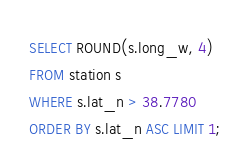<code> <loc_0><loc_0><loc_500><loc_500><_SQL_>SELECT ROUND(s.long_w, 4)
FROM station s
WHERE s.lat_n > 38.7780
ORDER BY s.lat_n ASC LIMIT 1;
</code> 